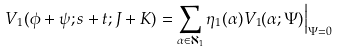Convert formula to latex. <formula><loc_0><loc_0><loc_500><loc_500>V _ { 1 } ( \phi + \psi ; s + t ; J + K ) & = \sum _ { \alpha \in \aleph _ { 1 } } \eta _ { 1 } ( \alpha ) V _ { 1 } ( \alpha ; \Psi ) \Big | _ { \Psi = 0 }</formula> 